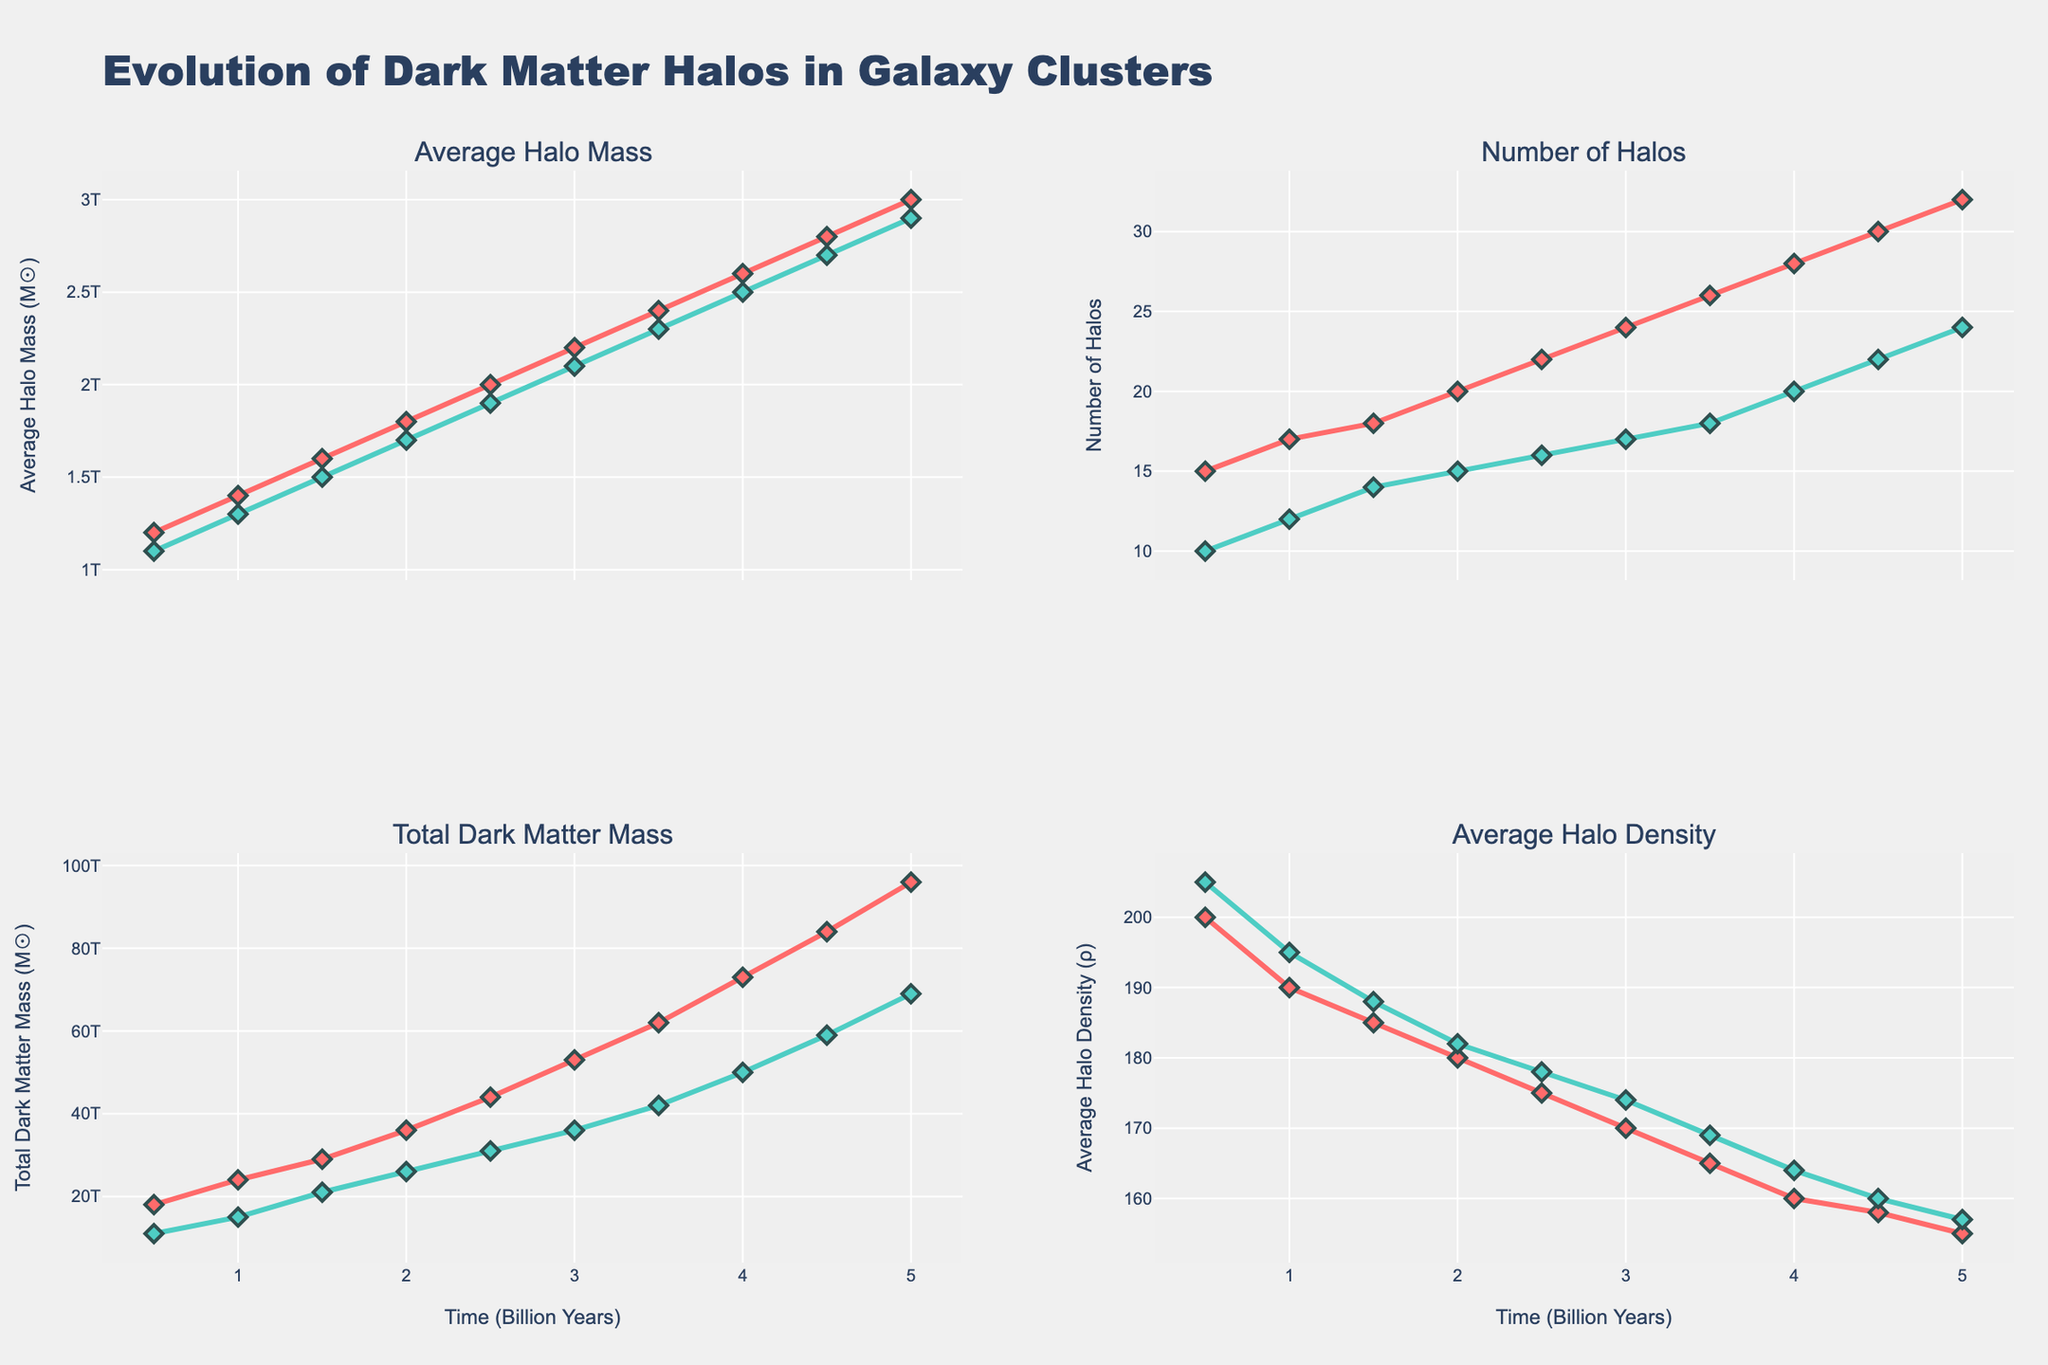What is the title of the figure? The title of the figure is usually located at the top center. Here, it clearly states "Evolution of Dark Matter Halos in Galaxy Clusters".
Answer: Evolution of Dark Matter Halos in Galaxy Clusters How does the average halo mass of the Virgo cluster change over time? By examining the 'Average Halo Mass' plot for the Virgo cluster, you can see that the average mass increases as time progresses. Initially starting at 1.2e12 and reaching 3.0e12 at 5 billion years.
Answer: It increases Which cluster has a higher average halo density at 2 billion years, Virgo or Coma? Look at the 'Average Halo Density' plot. At 2 billion years, Virgo's average halo density is 180, while Coma's average halo density is 182.
Answer: Coma What is the difference in total dark matter mass between Virgo and Coma at 5 billion years? Check the 'Total Dark Matter Mass' plots for both Virgo and Coma. At 5 billion years, Virgo has a total mass of 9.6e13 and Coma has 6.9e13. The difference is 9.6e13 - 6.9e13 = 2.7e13.
Answer: 2.7e13 Which cluster experiences a larger increase in the number of halos between 1 and 3 billion years? For Virgo, the number of halos increases from 17 to 24, a difference of 7. For Coma, it goes from 12 to 17, a difference of 5. Virgo has a larger increase.
Answer: Virgo At what time does the average halo mass reach 2.0e12 for both clusters? In the 'Average Halo Mass' plot, for Virgo it reaches 2.0e12 at 2.5 billion years, and for Coma it reaches 2.0e12 at 3 billion years.
Answer: 2.5 billion years for Virgo, 3 billion years for Coma How do the trends in 'Average Halo Mass' compare between the two clusters? Examine both plots for Virgo and Coma. Both show an upward trend but start and increase slightly differently. Specifically, Virgo starts at a higher average mass and increases more consistently and steeply over time compared to Coma.
Answer: Similar upward trends, Virgo starts higher and increases more steeply Calculate the average 'Number of Halos' for Virgo across the entire observed period. Sum the number of halos over all time points for Virgo: 15 + 17 + 18 + 20 + 22 + 24 + 26 + 28 + 30 + 32 = 232. There are 10 time points, so the average is 232 / 10.
Answer: 23.2 At 4 billion years, which metric shows the largest difference between Virgo and Coma? At 4 billion years, compare the differences in 'Average Halo Mass', 'Number of Halos', 'Total Dark Matter Mass', and 'Average Halo Density' between Virgo and Coma. The total dark matter mass difference (7.3e13 for Virgo vs. 5.0e13 for Coma) has the largest difference of 2.3e13.
Answer: Total Dark Matter Mass What is the trend in 'Average Halo Density' for both clusters? Look at the 'Average Halo Density' plot for both clusters. Both Virgo and Coma show a decreasing trend over time.
Answer: Decreasing trend 